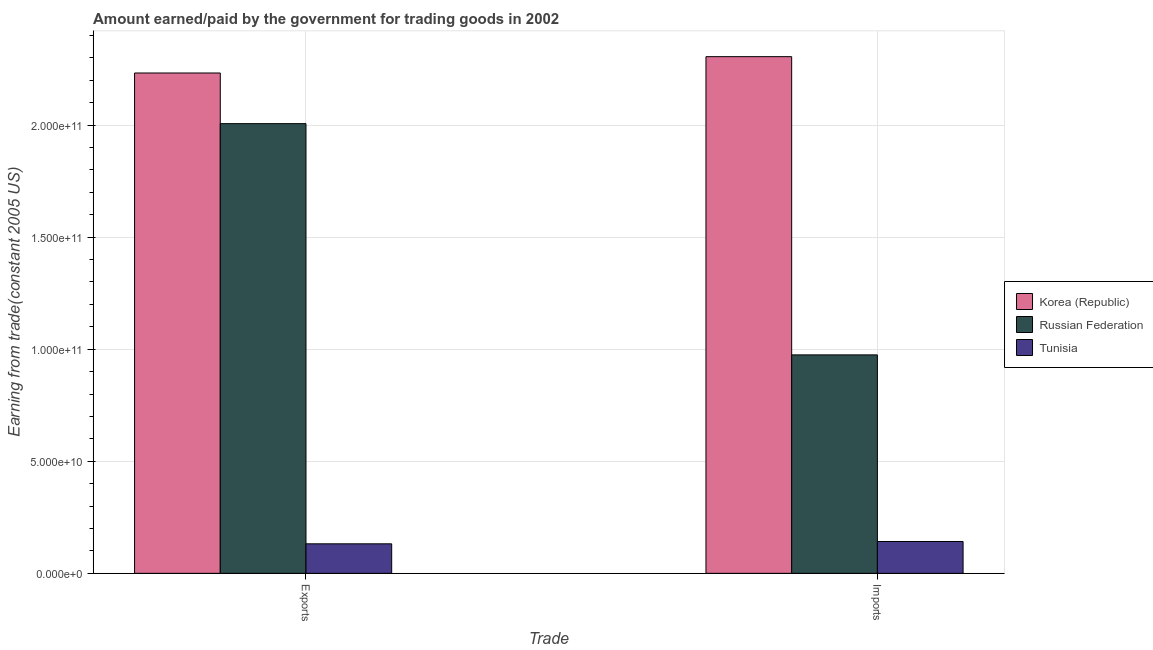How many groups of bars are there?
Provide a succinct answer. 2. Are the number of bars per tick equal to the number of legend labels?
Provide a succinct answer. Yes. Are the number of bars on each tick of the X-axis equal?
Ensure brevity in your answer.  Yes. How many bars are there on the 1st tick from the right?
Your answer should be very brief. 3. What is the label of the 2nd group of bars from the left?
Keep it short and to the point. Imports. What is the amount paid for imports in Russian Federation?
Ensure brevity in your answer.  9.75e+1. Across all countries, what is the maximum amount earned from exports?
Ensure brevity in your answer.  2.23e+11. Across all countries, what is the minimum amount paid for imports?
Keep it short and to the point. 1.42e+1. In which country was the amount paid for imports minimum?
Your response must be concise. Tunisia. What is the total amount paid for imports in the graph?
Your response must be concise. 3.42e+11. What is the difference between the amount earned from exports in Korea (Republic) and that in Russian Federation?
Offer a terse response. 2.26e+1. What is the difference between the amount paid for imports in Russian Federation and the amount earned from exports in Tunisia?
Provide a short and direct response. 8.43e+1. What is the average amount earned from exports per country?
Keep it short and to the point. 1.46e+11. What is the difference between the amount paid for imports and amount earned from exports in Russian Federation?
Your answer should be very brief. -1.03e+11. In how many countries, is the amount earned from exports greater than 200000000000 US$?
Make the answer very short. 2. What is the ratio of the amount paid for imports in Tunisia to that in Korea (Republic)?
Ensure brevity in your answer.  0.06. Is the amount earned from exports in Korea (Republic) less than that in Tunisia?
Offer a terse response. No. In how many countries, is the amount earned from exports greater than the average amount earned from exports taken over all countries?
Ensure brevity in your answer.  2. What does the 3rd bar from the left in Imports represents?
Your answer should be compact. Tunisia. What does the 1st bar from the right in Imports represents?
Your answer should be compact. Tunisia. How many bars are there?
Provide a short and direct response. 6. What is the difference between two consecutive major ticks on the Y-axis?
Ensure brevity in your answer.  5.00e+1. Are the values on the major ticks of Y-axis written in scientific E-notation?
Provide a short and direct response. Yes. Does the graph contain grids?
Provide a succinct answer. Yes. How many legend labels are there?
Keep it short and to the point. 3. What is the title of the graph?
Offer a very short reply. Amount earned/paid by the government for trading goods in 2002. Does "Faeroe Islands" appear as one of the legend labels in the graph?
Provide a succinct answer. No. What is the label or title of the X-axis?
Keep it short and to the point. Trade. What is the label or title of the Y-axis?
Provide a short and direct response. Earning from trade(constant 2005 US). What is the Earning from trade(constant 2005 US) in Korea (Republic) in Exports?
Make the answer very short. 2.23e+11. What is the Earning from trade(constant 2005 US) in Russian Federation in Exports?
Offer a very short reply. 2.01e+11. What is the Earning from trade(constant 2005 US) in Tunisia in Exports?
Make the answer very short. 1.32e+1. What is the Earning from trade(constant 2005 US) in Korea (Republic) in Imports?
Your answer should be compact. 2.30e+11. What is the Earning from trade(constant 2005 US) in Russian Federation in Imports?
Offer a very short reply. 9.75e+1. What is the Earning from trade(constant 2005 US) in Tunisia in Imports?
Make the answer very short. 1.42e+1. Across all Trade, what is the maximum Earning from trade(constant 2005 US) of Korea (Republic)?
Make the answer very short. 2.30e+11. Across all Trade, what is the maximum Earning from trade(constant 2005 US) in Russian Federation?
Keep it short and to the point. 2.01e+11. Across all Trade, what is the maximum Earning from trade(constant 2005 US) in Tunisia?
Make the answer very short. 1.42e+1. Across all Trade, what is the minimum Earning from trade(constant 2005 US) of Korea (Republic)?
Give a very brief answer. 2.23e+11. Across all Trade, what is the minimum Earning from trade(constant 2005 US) of Russian Federation?
Keep it short and to the point. 9.75e+1. Across all Trade, what is the minimum Earning from trade(constant 2005 US) of Tunisia?
Your response must be concise. 1.32e+1. What is the total Earning from trade(constant 2005 US) in Korea (Republic) in the graph?
Offer a very short reply. 4.54e+11. What is the total Earning from trade(constant 2005 US) of Russian Federation in the graph?
Ensure brevity in your answer.  2.98e+11. What is the total Earning from trade(constant 2005 US) in Tunisia in the graph?
Your response must be concise. 2.74e+1. What is the difference between the Earning from trade(constant 2005 US) in Korea (Republic) in Exports and that in Imports?
Offer a terse response. -7.29e+09. What is the difference between the Earning from trade(constant 2005 US) in Russian Federation in Exports and that in Imports?
Your answer should be very brief. 1.03e+11. What is the difference between the Earning from trade(constant 2005 US) in Tunisia in Exports and that in Imports?
Provide a succinct answer. -1.04e+09. What is the difference between the Earning from trade(constant 2005 US) of Korea (Republic) in Exports and the Earning from trade(constant 2005 US) of Russian Federation in Imports?
Offer a terse response. 1.26e+11. What is the difference between the Earning from trade(constant 2005 US) in Korea (Republic) in Exports and the Earning from trade(constant 2005 US) in Tunisia in Imports?
Your answer should be very brief. 2.09e+11. What is the difference between the Earning from trade(constant 2005 US) of Russian Federation in Exports and the Earning from trade(constant 2005 US) of Tunisia in Imports?
Offer a terse response. 1.86e+11. What is the average Earning from trade(constant 2005 US) of Korea (Republic) per Trade?
Provide a succinct answer. 2.27e+11. What is the average Earning from trade(constant 2005 US) in Russian Federation per Trade?
Ensure brevity in your answer.  1.49e+11. What is the average Earning from trade(constant 2005 US) in Tunisia per Trade?
Provide a short and direct response. 1.37e+1. What is the difference between the Earning from trade(constant 2005 US) in Korea (Republic) and Earning from trade(constant 2005 US) in Russian Federation in Exports?
Your response must be concise. 2.26e+1. What is the difference between the Earning from trade(constant 2005 US) of Korea (Republic) and Earning from trade(constant 2005 US) of Tunisia in Exports?
Keep it short and to the point. 2.10e+11. What is the difference between the Earning from trade(constant 2005 US) of Russian Federation and Earning from trade(constant 2005 US) of Tunisia in Exports?
Ensure brevity in your answer.  1.87e+11. What is the difference between the Earning from trade(constant 2005 US) of Korea (Republic) and Earning from trade(constant 2005 US) of Russian Federation in Imports?
Your answer should be compact. 1.33e+11. What is the difference between the Earning from trade(constant 2005 US) of Korea (Republic) and Earning from trade(constant 2005 US) of Tunisia in Imports?
Provide a short and direct response. 2.16e+11. What is the difference between the Earning from trade(constant 2005 US) of Russian Federation and Earning from trade(constant 2005 US) of Tunisia in Imports?
Give a very brief answer. 8.32e+1. What is the ratio of the Earning from trade(constant 2005 US) in Korea (Republic) in Exports to that in Imports?
Give a very brief answer. 0.97. What is the ratio of the Earning from trade(constant 2005 US) in Russian Federation in Exports to that in Imports?
Your answer should be very brief. 2.06. What is the ratio of the Earning from trade(constant 2005 US) of Tunisia in Exports to that in Imports?
Ensure brevity in your answer.  0.93. What is the difference between the highest and the second highest Earning from trade(constant 2005 US) in Korea (Republic)?
Your answer should be compact. 7.29e+09. What is the difference between the highest and the second highest Earning from trade(constant 2005 US) in Russian Federation?
Your response must be concise. 1.03e+11. What is the difference between the highest and the second highest Earning from trade(constant 2005 US) of Tunisia?
Keep it short and to the point. 1.04e+09. What is the difference between the highest and the lowest Earning from trade(constant 2005 US) in Korea (Republic)?
Give a very brief answer. 7.29e+09. What is the difference between the highest and the lowest Earning from trade(constant 2005 US) in Russian Federation?
Keep it short and to the point. 1.03e+11. What is the difference between the highest and the lowest Earning from trade(constant 2005 US) in Tunisia?
Give a very brief answer. 1.04e+09. 